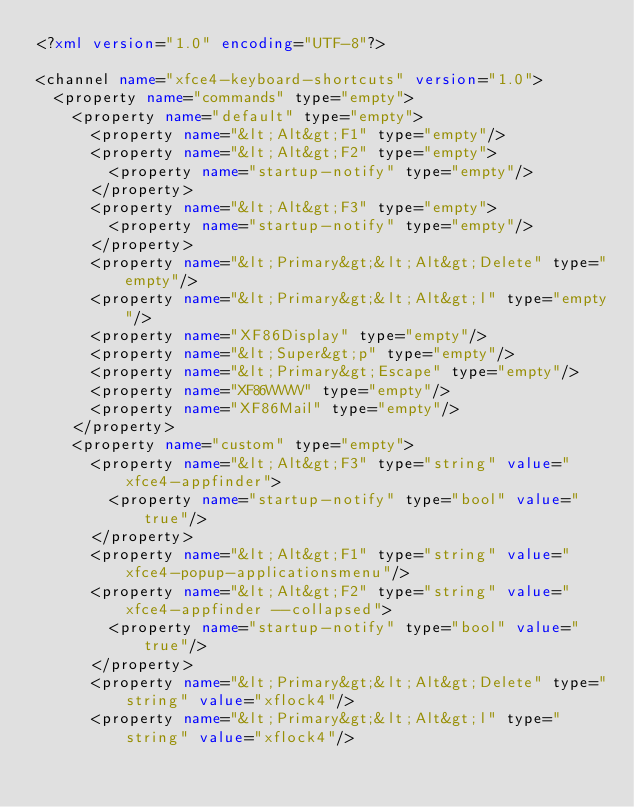<code> <loc_0><loc_0><loc_500><loc_500><_XML_><?xml version="1.0" encoding="UTF-8"?>

<channel name="xfce4-keyboard-shortcuts" version="1.0">
  <property name="commands" type="empty">
    <property name="default" type="empty">
      <property name="&lt;Alt&gt;F1" type="empty"/>
      <property name="&lt;Alt&gt;F2" type="empty">
        <property name="startup-notify" type="empty"/>
      </property>
      <property name="&lt;Alt&gt;F3" type="empty">
        <property name="startup-notify" type="empty"/>
      </property>
      <property name="&lt;Primary&gt;&lt;Alt&gt;Delete" type="empty"/>
      <property name="&lt;Primary&gt;&lt;Alt&gt;l" type="empty"/>
      <property name="XF86Display" type="empty"/>
      <property name="&lt;Super&gt;p" type="empty"/>
      <property name="&lt;Primary&gt;Escape" type="empty"/>
      <property name="XF86WWW" type="empty"/>
      <property name="XF86Mail" type="empty"/>
    </property>
    <property name="custom" type="empty">
      <property name="&lt;Alt&gt;F3" type="string" value="xfce4-appfinder">
        <property name="startup-notify" type="bool" value="true"/>
      </property>
      <property name="&lt;Alt&gt;F1" type="string" value="xfce4-popup-applicationsmenu"/>
      <property name="&lt;Alt&gt;F2" type="string" value="xfce4-appfinder --collapsed">
        <property name="startup-notify" type="bool" value="true"/>
      </property>
      <property name="&lt;Primary&gt;&lt;Alt&gt;Delete" type="string" value="xflock4"/>
      <property name="&lt;Primary&gt;&lt;Alt&gt;l" type="string" value="xflock4"/></code> 